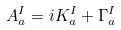<formula> <loc_0><loc_0><loc_500><loc_500>A _ { a } ^ { I } = i K _ { a } ^ { I } + { \Gamma } _ { a } ^ { I }</formula> 